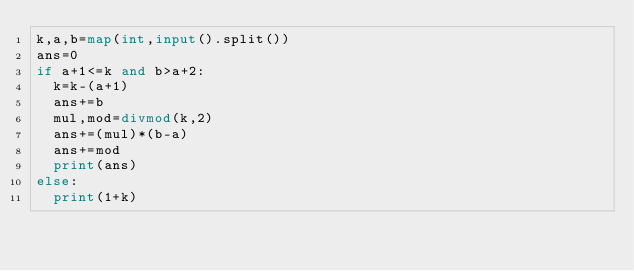<code> <loc_0><loc_0><loc_500><loc_500><_Python_>k,a,b=map(int,input().split())
ans=0
if a+1<=k and b>a+2:
  k=k-(a+1)
  ans+=b
  mul,mod=divmod(k,2)
  ans+=(mul)*(b-a)
  ans+=mod
  print(ans)
else:
  print(1+k)
</code> 